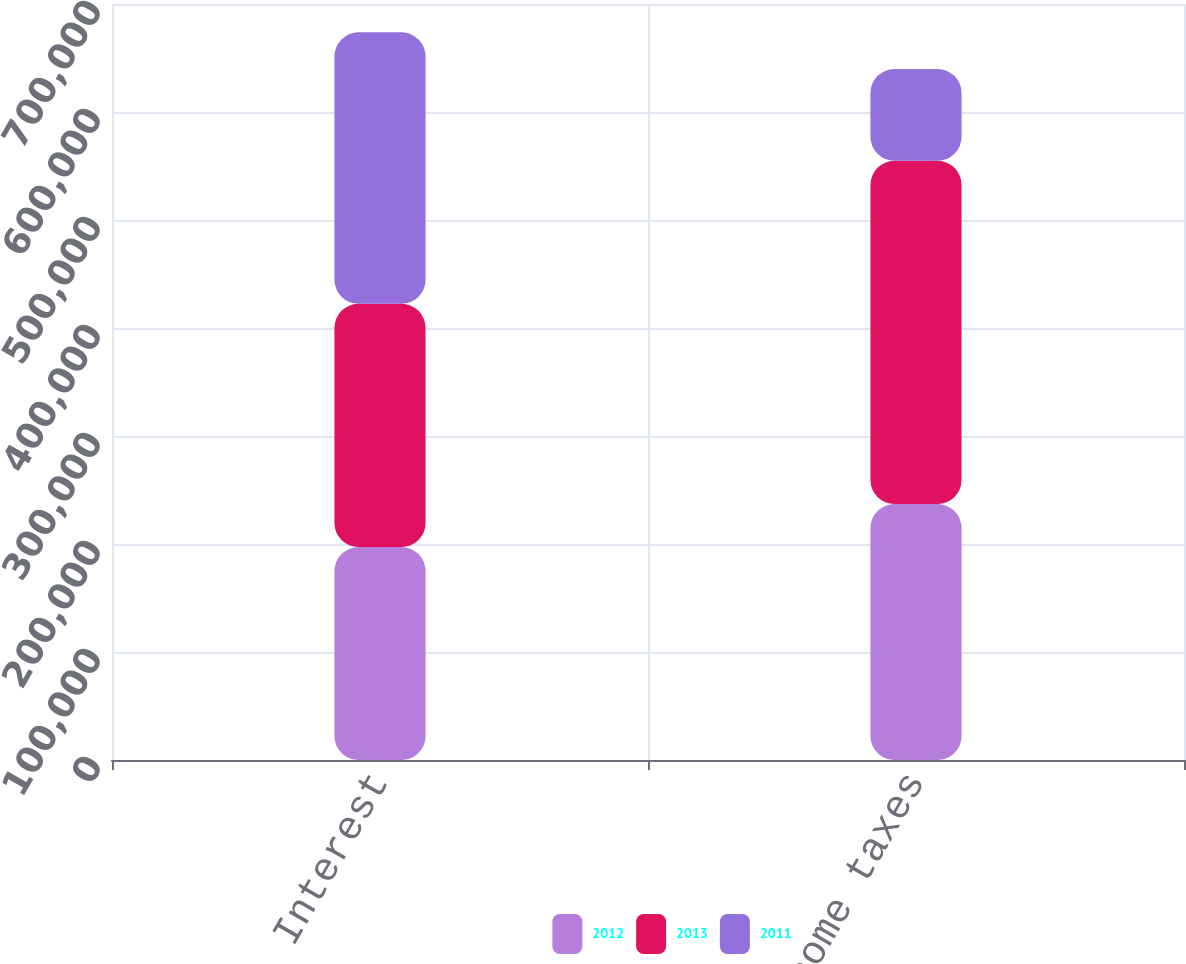Convert chart. <chart><loc_0><loc_0><loc_500><loc_500><stacked_bar_chart><ecel><fcel>Interest<fcel>Income taxes<nl><fcel>2012<fcel>197161<fcel>236972<nl><fcel>2013<fcel>225228<fcel>317812<nl><fcel>2011<fcel>251341<fcel>84984<nl></chart> 